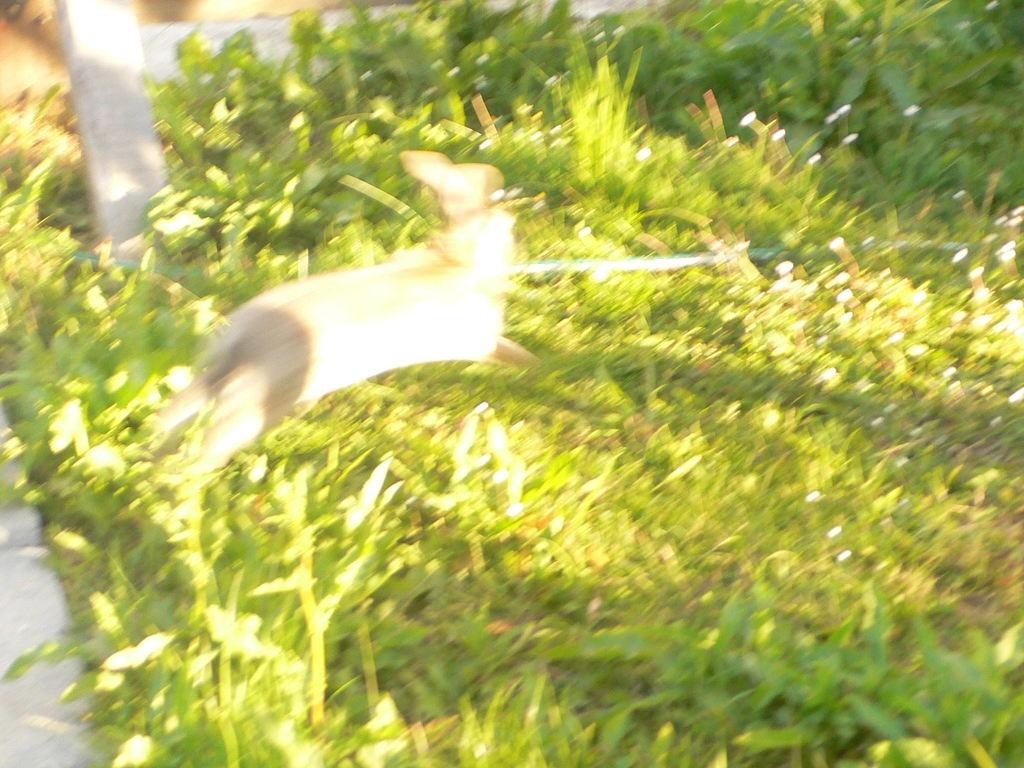What is the overall quality of the image? The image appears to be blurry. What type of terrain is visible in the image? There is grass visible on the ground. What type of vegetation is present in the image? There are plants in the image. Can you describe any other objects in the image besides the plants? Yes, there are other objects in the image. What type of steam is rising from the plants in the image? There is no steam present in the image; it only features plants and other objects. 